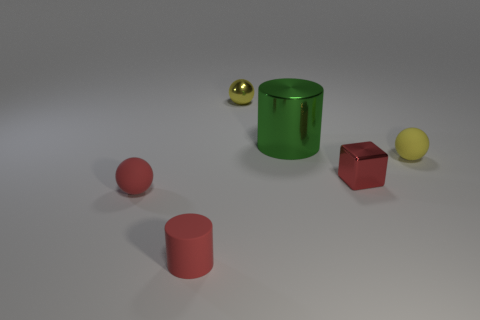Add 1 small purple things. How many objects exist? 7 Subtract all blocks. How many objects are left? 5 Subtract 0 cyan cylinders. How many objects are left? 6 Subtract all green objects. Subtract all tiny red cylinders. How many objects are left? 4 Add 4 tiny yellow metal things. How many tiny yellow metal things are left? 5 Add 4 large things. How many large things exist? 5 